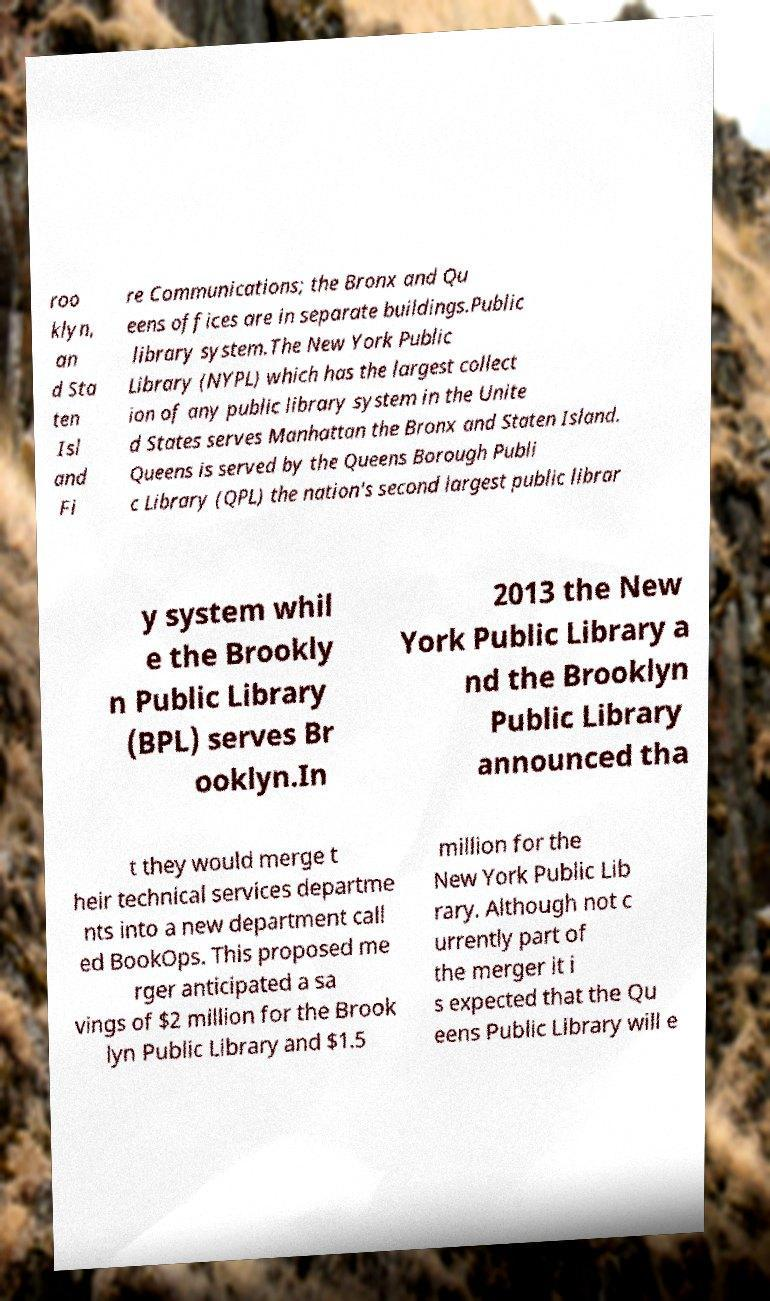Please identify and transcribe the text found in this image. roo klyn, an d Sta ten Isl and Fi re Communications; the Bronx and Qu eens offices are in separate buildings.Public library system.The New York Public Library (NYPL) which has the largest collect ion of any public library system in the Unite d States serves Manhattan the Bronx and Staten Island. Queens is served by the Queens Borough Publi c Library (QPL) the nation's second largest public librar y system whil e the Brookly n Public Library (BPL) serves Br ooklyn.In 2013 the New York Public Library a nd the Brooklyn Public Library announced tha t they would merge t heir technical services departme nts into a new department call ed BookOps. This proposed me rger anticipated a sa vings of $2 million for the Brook lyn Public Library and $1.5 million for the New York Public Lib rary. Although not c urrently part of the merger it i s expected that the Qu eens Public Library will e 